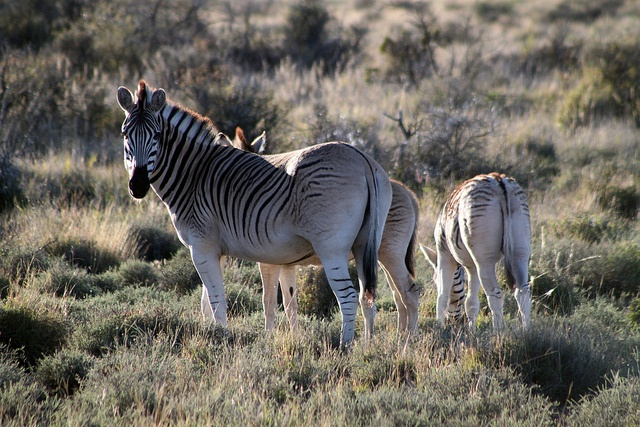Describe the objects in this image and their specific colors. I can see zebra in black and gray tones, zebra in black, gray, darkgray, and white tones, and zebra in black, gray, and darkgray tones in this image. 